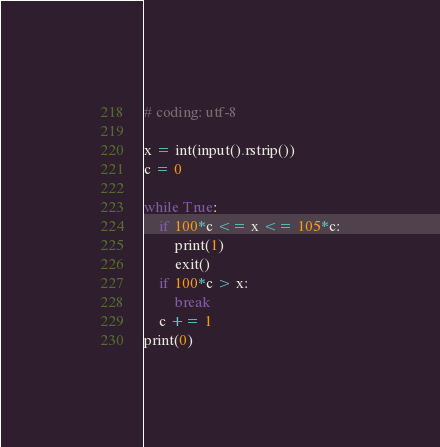<code> <loc_0><loc_0><loc_500><loc_500><_Python_># coding: utf-8

x = int(input().rstrip())
c = 0

while True:
    if 100*c <= x <= 105*c:
        print(1)
        exit()
    if 100*c > x:
        break
    c += 1
print(0)</code> 